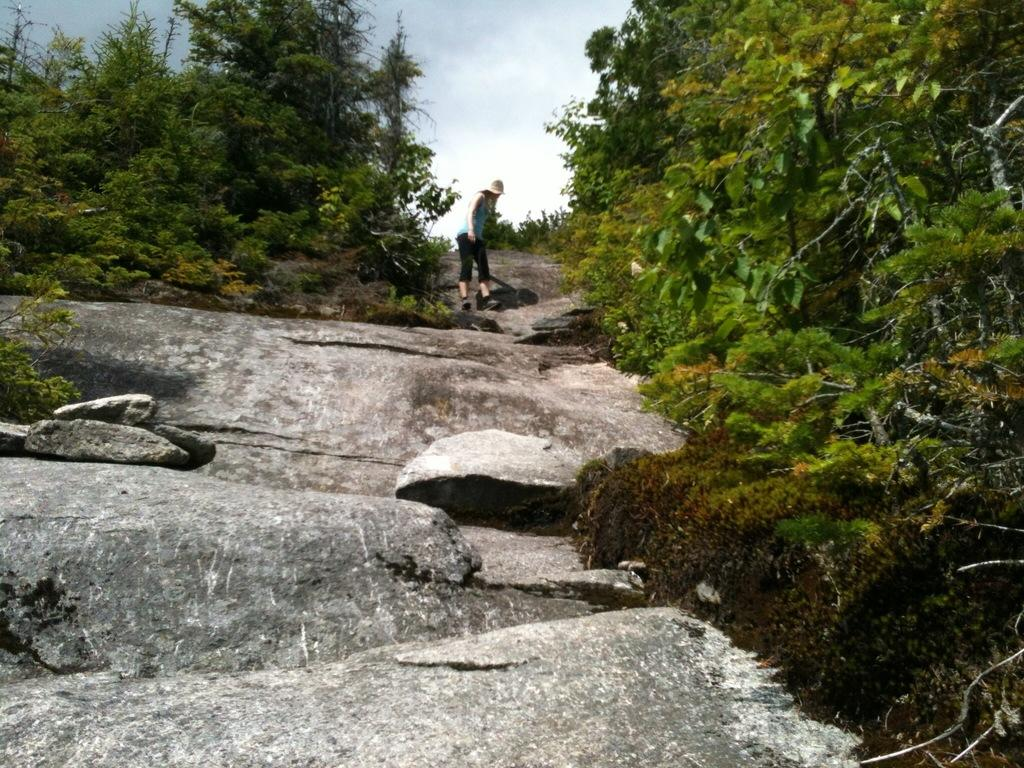What type of vegetation can be seen in the image? There are trees in the image. Can you describe the person in the image? There is a person standing in the image. What is visible in the background of the image? The sky is visible in the image. What is the aftermath of the event that took place near the coast in the image? There is no event or coast mentioned in the image, so it is not possible to answer a question about the aftermath. 